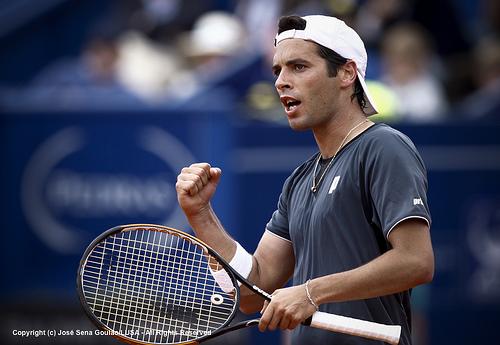What is he doing with his other hand?
Answer briefly. Making fist. Which hand is dominant?
Answer briefly. Left. Is his hat on forward or backward?
Write a very short answer. Backward. Is he holding a racket?
Concise answer only. Yes. 